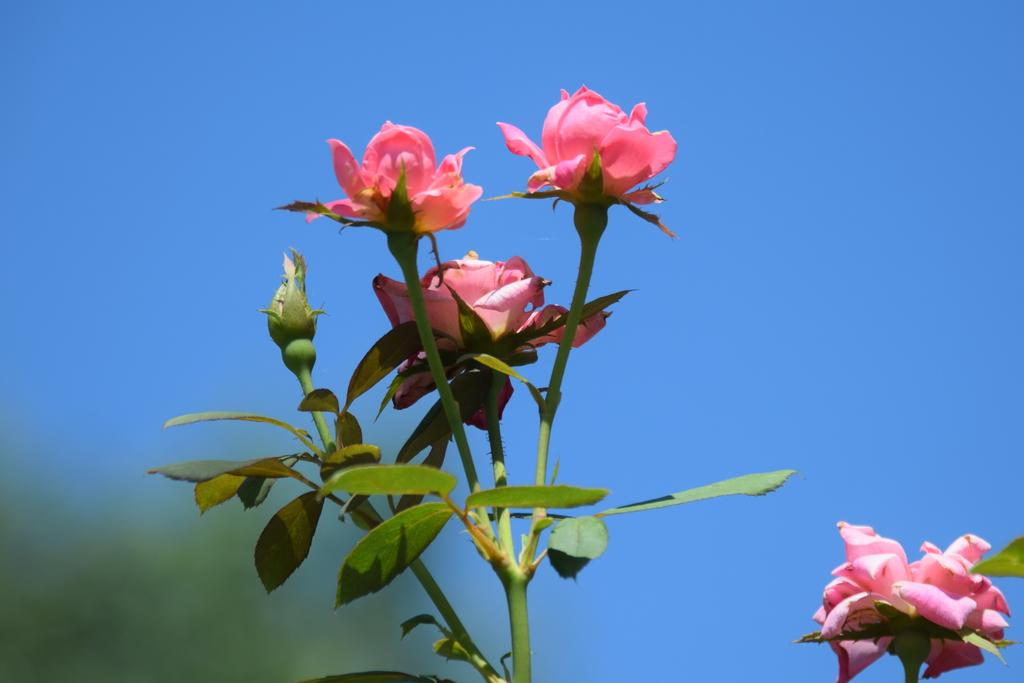What type of flowers are in the image? There are rose flowers in the image. What parts of the rose flowers are visible? The rose flowers have stems and leaves. Is there a rose flower in a specific stage of growth in the image? Yes, there is a rose bud in the image. What can be seen in the background of the image? The sky is visible in the background of the image. What type of animal can be seen taking a journey in the image? There are no animals or journeys present in the image; it features rose flowers with stems, leaves, and a rose bud. 